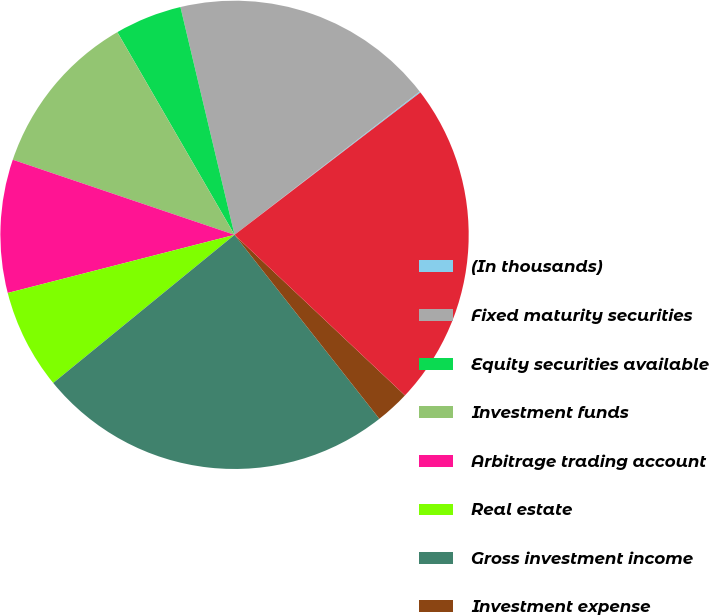Convert chart to OTSL. <chart><loc_0><loc_0><loc_500><loc_500><pie_chart><fcel>(In thousands)<fcel>Fixed maturity securities<fcel>Equity securities available<fcel>Investment funds<fcel>Arbitrage trading account<fcel>Real estate<fcel>Gross investment income<fcel>Investment expense<fcel>Net investment income<nl><fcel>0.08%<fcel>18.23%<fcel>4.63%<fcel>11.46%<fcel>9.19%<fcel>6.91%<fcel>24.71%<fcel>2.36%<fcel>22.43%<nl></chart> 